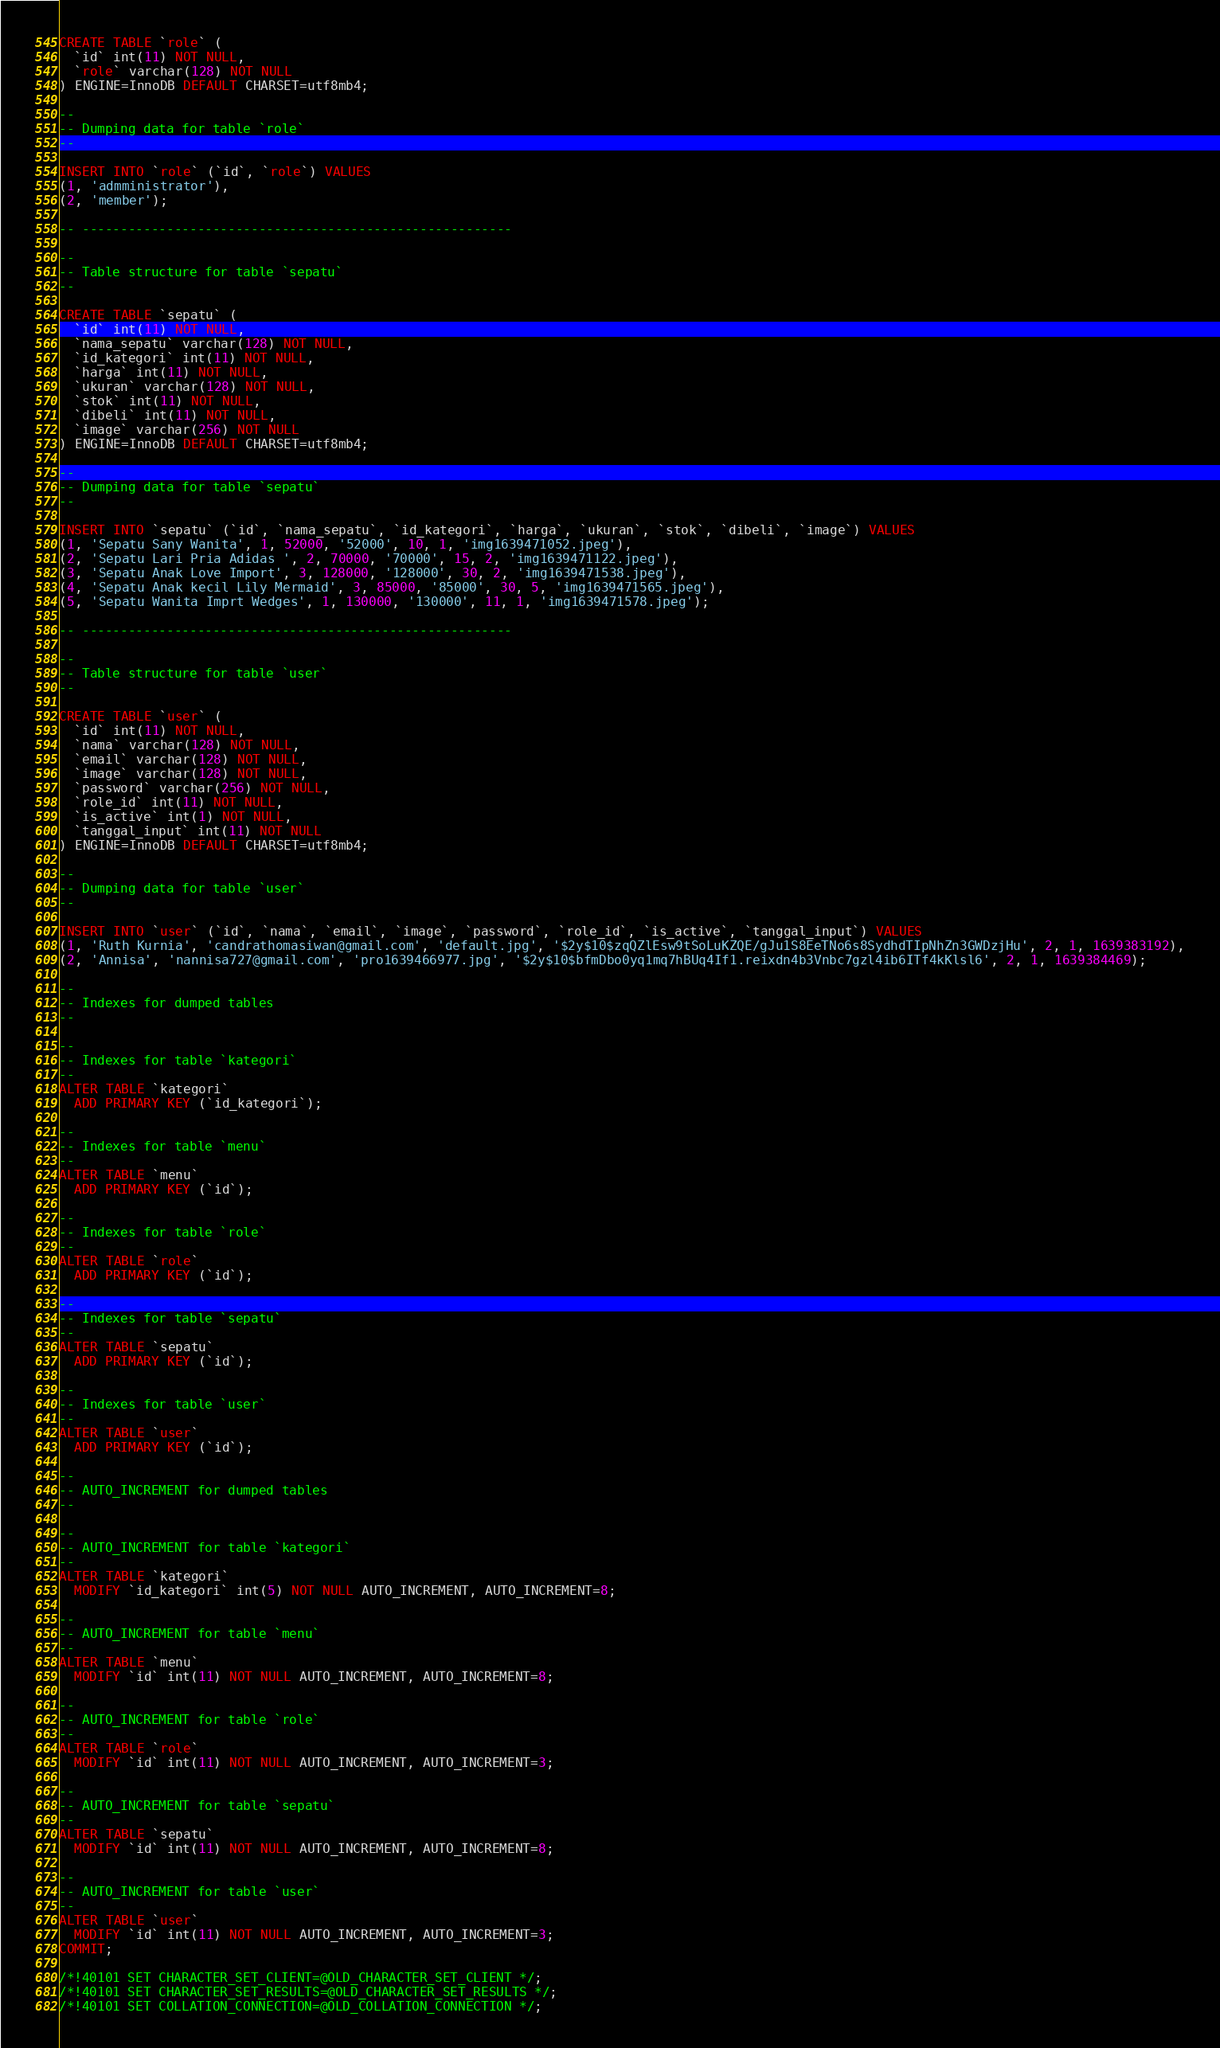<code> <loc_0><loc_0><loc_500><loc_500><_SQL_>
CREATE TABLE `role` (
  `id` int(11) NOT NULL,
  `role` varchar(128) NOT NULL
) ENGINE=InnoDB DEFAULT CHARSET=utf8mb4;

--
-- Dumping data for table `role`
--

INSERT INTO `role` (`id`, `role`) VALUES
(1, 'admministrator'),
(2, 'member');

-- --------------------------------------------------------

--
-- Table structure for table `sepatu`
--

CREATE TABLE `sepatu` (
  `id` int(11) NOT NULL,
  `nama_sepatu` varchar(128) NOT NULL,
  `id_kategori` int(11) NOT NULL,
  `harga` int(11) NOT NULL,
  `ukuran` varchar(128) NOT NULL,
  `stok` int(11) NOT NULL,
  `dibeli` int(11) NOT NULL,
  `image` varchar(256) NOT NULL
) ENGINE=InnoDB DEFAULT CHARSET=utf8mb4;

--
-- Dumping data for table `sepatu`
--

INSERT INTO `sepatu` (`id`, `nama_sepatu`, `id_kategori`, `harga`, `ukuran`, `stok`, `dibeli`, `image`) VALUES
(1, 'Sepatu Sany Wanita', 1, 52000, '52000', 10, 1, 'img1639471052.jpeg'),
(2, 'Sepatu Lari Pria Adidas ', 2, 70000, '70000', 15, 2, 'img1639471122.jpeg'),
(3, 'Sepatu Anak Love Import', 3, 128000, '128000', 30, 2, 'img1639471538.jpeg'),
(4, 'Sepatu Anak kecil Lily Mermaid', 3, 85000, '85000', 30, 5, 'img1639471565.jpeg'),
(5, 'Sepatu Wanita Imprt Wedges', 1, 130000, '130000', 11, 1, 'img1639471578.jpeg');

-- --------------------------------------------------------

--
-- Table structure for table `user`
--

CREATE TABLE `user` (
  `id` int(11) NOT NULL,
  `nama` varchar(128) NOT NULL,
  `email` varchar(128) NOT NULL,
  `image` varchar(128) NOT NULL,
  `password` varchar(256) NOT NULL,
  `role_id` int(11) NOT NULL,
  `is_active` int(1) NOT NULL,
  `tanggal_input` int(11) NOT NULL
) ENGINE=InnoDB DEFAULT CHARSET=utf8mb4;

--
-- Dumping data for table `user`
--

INSERT INTO `user` (`id`, `nama`, `email`, `image`, `password`, `role_id`, `is_active`, `tanggal_input`) VALUES
(1, 'Ruth Kurnia', 'candrathomasiwan@gmail.com', 'default.jpg', '$2y$10$zqQZlEsw9tSoLuKZQE/gJu1S8EeTNo6s8SydhdTIpNhZn3GWDzjHu', 2, 1, 1639383192),
(2, 'Annisa', 'nannisa727@gmail.com', 'pro1639466977.jpg', '$2y$10$bfmDbo0yq1mq7hBUq4If1.reixdn4b3Vnbc7gzl4ib6ITf4kKlsl6', 2, 1, 1639384469);

--
-- Indexes for dumped tables
--

--
-- Indexes for table `kategori`
--
ALTER TABLE `kategori`
  ADD PRIMARY KEY (`id_kategori`);

--
-- Indexes for table `menu`
--
ALTER TABLE `menu`
  ADD PRIMARY KEY (`id`);

--
-- Indexes for table `role`
--
ALTER TABLE `role`
  ADD PRIMARY KEY (`id`);

--
-- Indexes for table `sepatu`
--
ALTER TABLE `sepatu`
  ADD PRIMARY KEY (`id`);

--
-- Indexes for table `user`
--
ALTER TABLE `user`
  ADD PRIMARY KEY (`id`);

--
-- AUTO_INCREMENT for dumped tables
--

--
-- AUTO_INCREMENT for table `kategori`
--
ALTER TABLE `kategori`
  MODIFY `id_kategori` int(5) NOT NULL AUTO_INCREMENT, AUTO_INCREMENT=8;

--
-- AUTO_INCREMENT for table `menu`
--
ALTER TABLE `menu`
  MODIFY `id` int(11) NOT NULL AUTO_INCREMENT, AUTO_INCREMENT=8;

--
-- AUTO_INCREMENT for table `role`
--
ALTER TABLE `role`
  MODIFY `id` int(11) NOT NULL AUTO_INCREMENT, AUTO_INCREMENT=3;

--
-- AUTO_INCREMENT for table `sepatu`
--
ALTER TABLE `sepatu`
  MODIFY `id` int(11) NOT NULL AUTO_INCREMENT, AUTO_INCREMENT=8;

--
-- AUTO_INCREMENT for table `user`
--
ALTER TABLE `user`
  MODIFY `id` int(11) NOT NULL AUTO_INCREMENT, AUTO_INCREMENT=3;
COMMIT;

/*!40101 SET CHARACTER_SET_CLIENT=@OLD_CHARACTER_SET_CLIENT */;
/*!40101 SET CHARACTER_SET_RESULTS=@OLD_CHARACTER_SET_RESULTS */;
/*!40101 SET COLLATION_CONNECTION=@OLD_COLLATION_CONNECTION */;
</code> 